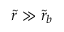<formula> <loc_0><loc_0><loc_500><loc_500>\tilde { r } \gg \tilde { r } _ { b }</formula> 